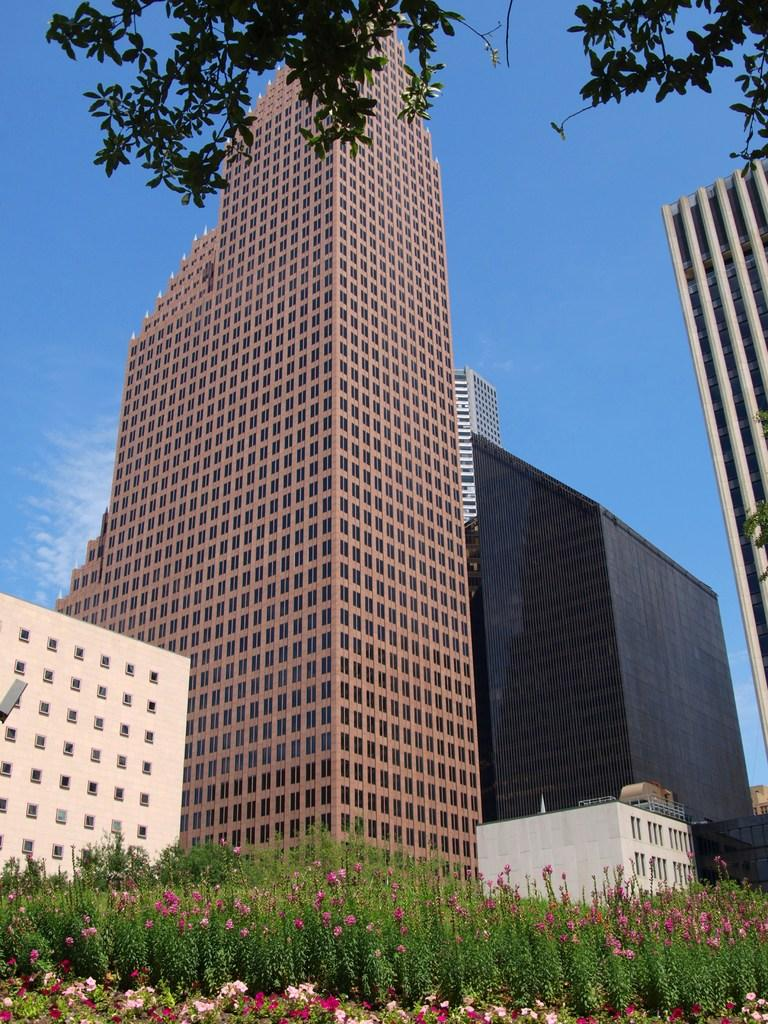What type of structures can be seen in the image? There are buildings in the image. What is visible in the background of the image? The sky is visible behind the buildings. What type of vegetation is at the bottom of the image? There are plants at the bottom of the image. What type of natural element is at the top of the image? There is a tree at the top of the image. What type of mine can be seen in the image? There is no mine present in the image. What type of playground equipment is visible in the image? There is no playground equipment visible in the image. 